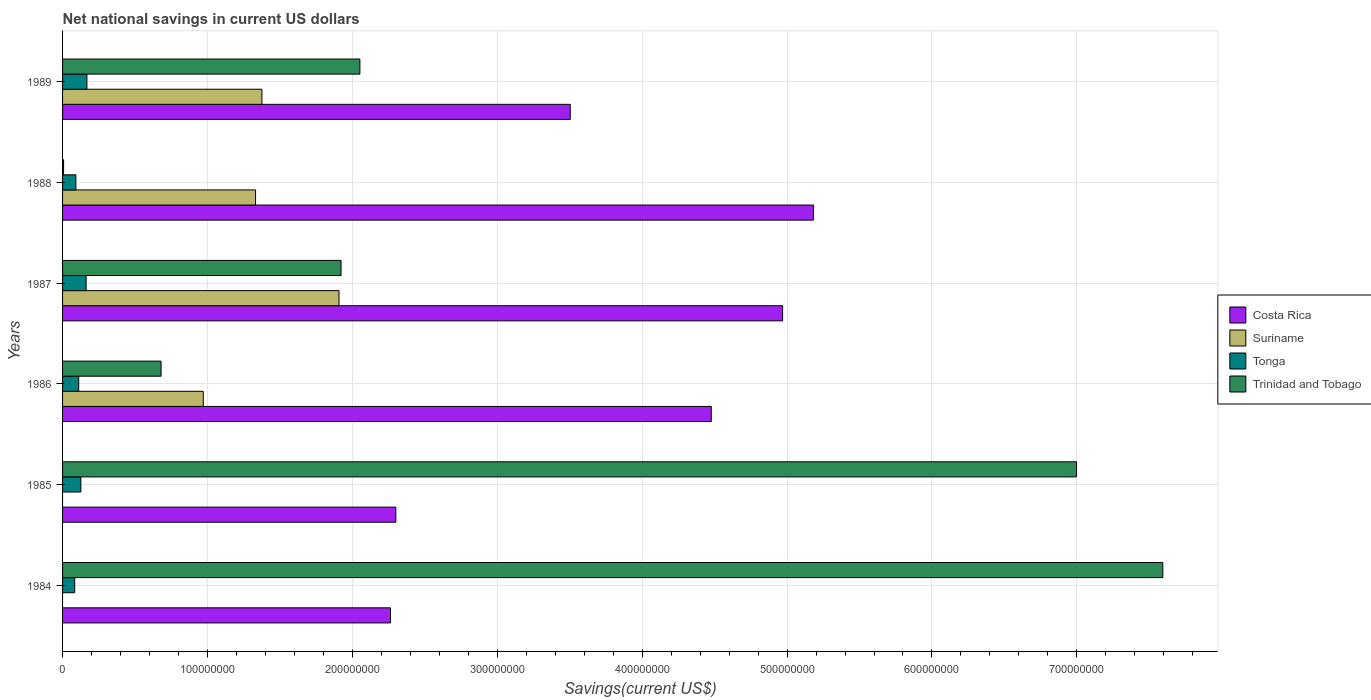How many different coloured bars are there?
Provide a succinct answer. 4. How many bars are there on the 6th tick from the bottom?
Offer a very short reply. 4. In how many cases, is the number of bars for a given year not equal to the number of legend labels?
Provide a succinct answer. 2. What is the net national savings in Tonga in 1986?
Provide a short and direct response. 1.11e+07. Across all years, what is the maximum net national savings in Trinidad and Tobago?
Your answer should be compact. 7.59e+08. Across all years, what is the minimum net national savings in Costa Rica?
Provide a short and direct response. 2.26e+08. In which year was the net national savings in Costa Rica maximum?
Make the answer very short. 1988. What is the total net national savings in Tonga in the graph?
Your answer should be compact. 7.44e+07. What is the difference between the net national savings in Trinidad and Tobago in 1986 and that in 1987?
Provide a short and direct response. -1.24e+08. What is the difference between the net national savings in Tonga in 1988 and the net national savings in Trinidad and Tobago in 1984?
Your response must be concise. -7.50e+08. What is the average net national savings in Suriname per year?
Keep it short and to the point. 9.31e+07. In the year 1988, what is the difference between the net national savings in Suriname and net national savings in Tonga?
Give a very brief answer. 1.24e+08. In how many years, is the net national savings in Suriname greater than 420000000 US$?
Offer a very short reply. 0. What is the ratio of the net national savings in Tonga in 1984 to that in 1989?
Your answer should be compact. 0.5. Is the net national savings in Costa Rica in 1984 less than that in 1986?
Offer a terse response. Yes. Is the difference between the net national savings in Suriname in 1988 and 1989 greater than the difference between the net national savings in Tonga in 1988 and 1989?
Provide a short and direct response. Yes. What is the difference between the highest and the second highest net national savings in Costa Rica?
Your answer should be compact. 2.13e+07. What is the difference between the highest and the lowest net national savings in Suriname?
Give a very brief answer. 1.91e+08. In how many years, is the net national savings in Tonga greater than the average net national savings in Tonga taken over all years?
Ensure brevity in your answer.  3. Is it the case that in every year, the sum of the net national savings in Trinidad and Tobago and net national savings in Tonga is greater than the sum of net national savings in Suriname and net national savings in Costa Rica?
Give a very brief answer. No. How many bars are there?
Give a very brief answer. 22. Are all the bars in the graph horizontal?
Give a very brief answer. Yes. How many years are there in the graph?
Your answer should be very brief. 6. What is the difference between two consecutive major ticks on the X-axis?
Make the answer very short. 1.00e+08. Does the graph contain any zero values?
Give a very brief answer. Yes. Does the graph contain grids?
Offer a very short reply. Yes. Where does the legend appear in the graph?
Provide a short and direct response. Center right. How many legend labels are there?
Ensure brevity in your answer.  4. How are the legend labels stacked?
Offer a very short reply. Vertical. What is the title of the graph?
Offer a very short reply. Net national savings in current US dollars. What is the label or title of the X-axis?
Offer a terse response. Savings(current US$). What is the label or title of the Y-axis?
Give a very brief answer. Years. What is the Savings(current US$) of Costa Rica in 1984?
Offer a very short reply. 2.26e+08. What is the Savings(current US$) in Suriname in 1984?
Provide a succinct answer. 0. What is the Savings(current US$) in Tonga in 1984?
Offer a terse response. 8.39e+06. What is the Savings(current US$) in Trinidad and Tobago in 1984?
Your answer should be very brief. 7.59e+08. What is the Savings(current US$) of Costa Rica in 1985?
Ensure brevity in your answer.  2.30e+08. What is the Savings(current US$) in Suriname in 1985?
Provide a succinct answer. 0. What is the Savings(current US$) in Tonga in 1985?
Keep it short and to the point. 1.26e+07. What is the Savings(current US$) in Trinidad and Tobago in 1985?
Make the answer very short. 7.00e+08. What is the Savings(current US$) in Costa Rica in 1986?
Make the answer very short. 4.48e+08. What is the Savings(current US$) of Suriname in 1986?
Your answer should be compact. 9.71e+07. What is the Savings(current US$) in Tonga in 1986?
Offer a terse response. 1.11e+07. What is the Savings(current US$) of Trinidad and Tobago in 1986?
Ensure brevity in your answer.  6.80e+07. What is the Savings(current US$) in Costa Rica in 1987?
Your answer should be very brief. 4.97e+08. What is the Savings(current US$) in Suriname in 1987?
Ensure brevity in your answer.  1.91e+08. What is the Savings(current US$) in Tonga in 1987?
Offer a terse response. 1.63e+07. What is the Savings(current US$) of Trinidad and Tobago in 1987?
Your answer should be compact. 1.92e+08. What is the Savings(current US$) of Costa Rica in 1988?
Offer a terse response. 5.18e+08. What is the Savings(current US$) of Suriname in 1988?
Your answer should be very brief. 1.33e+08. What is the Savings(current US$) of Tonga in 1988?
Provide a short and direct response. 9.19e+06. What is the Savings(current US$) in Trinidad and Tobago in 1988?
Keep it short and to the point. 7.15e+05. What is the Savings(current US$) in Costa Rica in 1989?
Provide a short and direct response. 3.50e+08. What is the Savings(current US$) in Suriname in 1989?
Ensure brevity in your answer.  1.38e+08. What is the Savings(current US$) of Tonga in 1989?
Offer a very short reply. 1.68e+07. What is the Savings(current US$) of Trinidad and Tobago in 1989?
Provide a short and direct response. 2.05e+08. Across all years, what is the maximum Savings(current US$) of Costa Rica?
Provide a succinct answer. 5.18e+08. Across all years, what is the maximum Savings(current US$) in Suriname?
Offer a terse response. 1.91e+08. Across all years, what is the maximum Savings(current US$) of Tonga?
Offer a terse response. 1.68e+07. Across all years, what is the maximum Savings(current US$) in Trinidad and Tobago?
Ensure brevity in your answer.  7.59e+08. Across all years, what is the minimum Savings(current US$) in Costa Rica?
Offer a very short reply. 2.26e+08. Across all years, what is the minimum Savings(current US$) in Suriname?
Offer a very short reply. 0. Across all years, what is the minimum Savings(current US$) in Tonga?
Make the answer very short. 8.39e+06. Across all years, what is the minimum Savings(current US$) of Trinidad and Tobago?
Provide a succinct answer. 7.15e+05. What is the total Savings(current US$) of Costa Rica in the graph?
Make the answer very short. 2.27e+09. What is the total Savings(current US$) in Suriname in the graph?
Your answer should be compact. 5.59e+08. What is the total Savings(current US$) in Tonga in the graph?
Ensure brevity in your answer.  7.44e+07. What is the total Savings(current US$) of Trinidad and Tobago in the graph?
Keep it short and to the point. 1.93e+09. What is the difference between the Savings(current US$) of Costa Rica in 1984 and that in 1985?
Make the answer very short. -3.69e+06. What is the difference between the Savings(current US$) in Tonga in 1984 and that in 1985?
Provide a short and direct response. -4.25e+06. What is the difference between the Savings(current US$) of Trinidad and Tobago in 1984 and that in 1985?
Your answer should be very brief. 5.95e+07. What is the difference between the Savings(current US$) in Costa Rica in 1984 and that in 1986?
Offer a very short reply. -2.21e+08. What is the difference between the Savings(current US$) of Tonga in 1984 and that in 1986?
Provide a succinct answer. -2.76e+06. What is the difference between the Savings(current US$) of Trinidad and Tobago in 1984 and that in 1986?
Offer a very short reply. 6.91e+08. What is the difference between the Savings(current US$) of Costa Rica in 1984 and that in 1987?
Offer a terse response. -2.71e+08. What is the difference between the Savings(current US$) of Tonga in 1984 and that in 1987?
Offer a terse response. -7.86e+06. What is the difference between the Savings(current US$) of Trinidad and Tobago in 1984 and that in 1987?
Ensure brevity in your answer.  5.67e+08. What is the difference between the Savings(current US$) in Costa Rica in 1984 and that in 1988?
Offer a very short reply. -2.92e+08. What is the difference between the Savings(current US$) in Tonga in 1984 and that in 1988?
Keep it short and to the point. -8.01e+05. What is the difference between the Savings(current US$) of Trinidad and Tobago in 1984 and that in 1988?
Ensure brevity in your answer.  7.59e+08. What is the difference between the Savings(current US$) in Costa Rica in 1984 and that in 1989?
Your response must be concise. -1.24e+08. What is the difference between the Savings(current US$) of Tonga in 1984 and that in 1989?
Give a very brief answer. -8.43e+06. What is the difference between the Savings(current US$) in Trinidad and Tobago in 1984 and that in 1989?
Your answer should be compact. 5.54e+08. What is the difference between the Savings(current US$) in Costa Rica in 1985 and that in 1986?
Offer a very short reply. -2.18e+08. What is the difference between the Savings(current US$) of Tonga in 1985 and that in 1986?
Your answer should be very brief. 1.49e+06. What is the difference between the Savings(current US$) in Trinidad and Tobago in 1985 and that in 1986?
Offer a terse response. 6.32e+08. What is the difference between the Savings(current US$) of Costa Rica in 1985 and that in 1987?
Make the answer very short. -2.67e+08. What is the difference between the Savings(current US$) of Tonga in 1985 and that in 1987?
Offer a terse response. -3.61e+06. What is the difference between the Savings(current US$) of Trinidad and Tobago in 1985 and that in 1987?
Make the answer very short. 5.08e+08. What is the difference between the Savings(current US$) in Costa Rica in 1985 and that in 1988?
Ensure brevity in your answer.  -2.88e+08. What is the difference between the Savings(current US$) in Tonga in 1985 and that in 1988?
Ensure brevity in your answer.  3.45e+06. What is the difference between the Savings(current US$) in Trinidad and Tobago in 1985 and that in 1988?
Your response must be concise. 6.99e+08. What is the difference between the Savings(current US$) of Costa Rica in 1985 and that in 1989?
Provide a succinct answer. -1.20e+08. What is the difference between the Savings(current US$) in Tonga in 1985 and that in 1989?
Provide a short and direct response. -4.18e+06. What is the difference between the Savings(current US$) in Trinidad and Tobago in 1985 and that in 1989?
Ensure brevity in your answer.  4.95e+08. What is the difference between the Savings(current US$) of Costa Rica in 1986 and that in 1987?
Offer a very short reply. -4.92e+07. What is the difference between the Savings(current US$) of Suriname in 1986 and that in 1987?
Provide a short and direct response. -9.37e+07. What is the difference between the Savings(current US$) of Tonga in 1986 and that in 1987?
Keep it short and to the point. -5.11e+06. What is the difference between the Savings(current US$) of Trinidad and Tobago in 1986 and that in 1987?
Your response must be concise. -1.24e+08. What is the difference between the Savings(current US$) of Costa Rica in 1986 and that in 1988?
Offer a very short reply. -7.05e+07. What is the difference between the Savings(current US$) in Suriname in 1986 and that in 1988?
Ensure brevity in your answer.  -3.61e+07. What is the difference between the Savings(current US$) in Tonga in 1986 and that in 1988?
Offer a very short reply. 1.96e+06. What is the difference between the Savings(current US$) in Trinidad and Tobago in 1986 and that in 1988?
Offer a very short reply. 6.73e+07. What is the difference between the Savings(current US$) in Costa Rica in 1986 and that in 1989?
Provide a succinct answer. 9.73e+07. What is the difference between the Savings(current US$) of Suriname in 1986 and that in 1989?
Provide a short and direct response. -4.05e+07. What is the difference between the Savings(current US$) of Tonga in 1986 and that in 1989?
Provide a short and direct response. -5.67e+06. What is the difference between the Savings(current US$) in Trinidad and Tobago in 1986 and that in 1989?
Provide a succinct answer. -1.37e+08. What is the difference between the Savings(current US$) of Costa Rica in 1987 and that in 1988?
Give a very brief answer. -2.13e+07. What is the difference between the Savings(current US$) of Suriname in 1987 and that in 1988?
Give a very brief answer. 5.76e+07. What is the difference between the Savings(current US$) in Tonga in 1987 and that in 1988?
Provide a short and direct response. 7.06e+06. What is the difference between the Savings(current US$) in Trinidad and Tobago in 1987 and that in 1988?
Provide a short and direct response. 1.91e+08. What is the difference between the Savings(current US$) in Costa Rica in 1987 and that in 1989?
Provide a short and direct response. 1.47e+08. What is the difference between the Savings(current US$) in Suriname in 1987 and that in 1989?
Provide a succinct answer. 5.32e+07. What is the difference between the Savings(current US$) of Tonga in 1987 and that in 1989?
Offer a very short reply. -5.68e+05. What is the difference between the Savings(current US$) of Trinidad and Tobago in 1987 and that in 1989?
Offer a very short reply. -1.30e+07. What is the difference between the Savings(current US$) in Costa Rica in 1988 and that in 1989?
Provide a short and direct response. 1.68e+08. What is the difference between the Savings(current US$) of Suriname in 1988 and that in 1989?
Make the answer very short. -4.38e+06. What is the difference between the Savings(current US$) of Tonga in 1988 and that in 1989?
Ensure brevity in your answer.  -7.63e+06. What is the difference between the Savings(current US$) of Trinidad and Tobago in 1988 and that in 1989?
Offer a very short reply. -2.04e+08. What is the difference between the Savings(current US$) of Costa Rica in 1984 and the Savings(current US$) of Tonga in 1985?
Provide a short and direct response. 2.14e+08. What is the difference between the Savings(current US$) of Costa Rica in 1984 and the Savings(current US$) of Trinidad and Tobago in 1985?
Your response must be concise. -4.73e+08. What is the difference between the Savings(current US$) of Tonga in 1984 and the Savings(current US$) of Trinidad and Tobago in 1985?
Keep it short and to the point. -6.91e+08. What is the difference between the Savings(current US$) of Costa Rica in 1984 and the Savings(current US$) of Suriname in 1986?
Provide a short and direct response. 1.29e+08. What is the difference between the Savings(current US$) in Costa Rica in 1984 and the Savings(current US$) in Tonga in 1986?
Your response must be concise. 2.15e+08. What is the difference between the Savings(current US$) of Costa Rica in 1984 and the Savings(current US$) of Trinidad and Tobago in 1986?
Your answer should be compact. 1.58e+08. What is the difference between the Savings(current US$) of Tonga in 1984 and the Savings(current US$) of Trinidad and Tobago in 1986?
Your answer should be compact. -5.96e+07. What is the difference between the Savings(current US$) of Costa Rica in 1984 and the Savings(current US$) of Suriname in 1987?
Your answer should be very brief. 3.55e+07. What is the difference between the Savings(current US$) in Costa Rica in 1984 and the Savings(current US$) in Tonga in 1987?
Your response must be concise. 2.10e+08. What is the difference between the Savings(current US$) in Costa Rica in 1984 and the Savings(current US$) in Trinidad and Tobago in 1987?
Offer a very short reply. 3.41e+07. What is the difference between the Savings(current US$) of Tonga in 1984 and the Savings(current US$) of Trinidad and Tobago in 1987?
Your answer should be very brief. -1.84e+08. What is the difference between the Savings(current US$) of Costa Rica in 1984 and the Savings(current US$) of Suriname in 1988?
Offer a very short reply. 9.31e+07. What is the difference between the Savings(current US$) in Costa Rica in 1984 and the Savings(current US$) in Tonga in 1988?
Keep it short and to the point. 2.17e+08. What is the difference between the Savings(current US$) in Costa Rica in 1984 and the Savings(current US$) in Trinidad and Tobago in 1988?
Provide a short and direct response. 2.26e+08. What is the difference between the Savings(current US$) of Tonga in 1984 and the Savings(current US$) of Trinidad and Tobago in 1988?
Keep it short and to the point. 7.67e+06. What is the difference between the Savings(current US$) of Costa Rica in 1984 and the Savings(current US$) of Suriname in 1989?
Offer a very short reply. 8.87e+07. What is the difference between the Savings(current US$) of Costa Rica in 1984 and the Savings(current US$) of Tonga in 1989?
Make the answer very short. 2.09e+08. What is the difference between the Savings(current US$) in Costa Rica in 1984 and the Savings(current US$) in Trinidad and Tobago in 1989?
Provide a short and direct response. 2.11e+07. What is the difference between the Savings(current US$) of Tonga in 1984 and the Savings(current US$) of Trinidad and Tobago in 1989?
Ensure brevity in your answer.  -1.97e+08. What is the difference between the Savings(current US$) of Costa Rica in 1985 and the Savings(current US$) of Suriname in 1986?
Your answer should be very brief. 1.33e+08. What is the difference between the Savings(current US$) of Costa Rica in 1985 and the Savings(current US$) of Tonga in 1986?
Your response must be concise. 2.19e+08. What is the difference between the Savings(current US$) in Costa Rica in 1985 and the Savings(current US$) in Trinidad and Tobago in 1986?
Your answer should be compact. 1.62e+08. What is the difference between the Savings(current US$) in Tonga in 1985 and the Savings(current US$) in Trinidad and Tobago in 1986?
Give a very brief answer. -5.53e+07. What is the difference between the Savings(current US$) in Costa Rica in 1985 and the Savings(current US$) in Suriname in 1987?
Your answer should be very brief. 3.92e+07. What is the difference between the Savings(current US$) of Costa Rica in 1985 and the Savings(current US$) of Tonga in 1987?
Your answer should be very brief. 2.14e+08. What is the difference between the Savings(current US$) in Costa Rica in 1985 and the Savings(current US$) in Trinidad and Tobago in 1987?
Your answer should be compact. 3.78e+07. What is the difference between the Savings(current US$) in Tonga in 1985 and the Savings(current US$) in Trinidad and Tobago in 1987?
Keep it short and to the point. -1.80e+08. What is the difference between the Savings(current US$) in Costa Rica in 1985 and the Savings(current US$) in Suriname in 1988?
Your answer should be very brief. 9.68e+07. What is the difference between the Savings(current US$) in Costa Rica in 1985 and the Savings(current US$) in Tonga in 1988?
Keep it short and to the point. 2.21e+08. What is the difference between the Savings(current US$) of Costa Rica in 1985 and the Savings(current US$) of Trinidad and Tobago in 1988?
Your response must be concise. 2.29e+08. What is the difference between the Savings(current US$) in Tonga in 1985 and the Savings(current US$) in Trinidad and Tobago in 1988?
Your answer should be compact. 1.19e+07. What is the difference between the Savings(current US$) of Costa Rica in 1985 and the Savings(current US$) of Suriname in 1989?
Your response must be concise. 9.24e+07. What is the difference between the Savings(current US$) in Costa Rica in 1985 and the Savings(current US$) in Tonga in 1989?
Give a very brief answer. 2.13e+08. What is the difference between the Savings(current US$) in Costa Rica in 1985 and the Savings(current US$) in Trinidad and Tobago in 1989?
Your answer should be very brief. 2.48e+07. What is the difference between the Savings(current US$) of Tonga in 1985 and the Savings(current US$) of Trinidad and Tobago in 1989?
Keep it short and to the point. -1.93e+08. What is the difference between the Savings(current US$) in Costa Rica in 1986 and the Savings(current US$) in Suriname in 1987?
Your answer should be very brief. 2.57e+08. What is the difference between the Savings(current US$) of Costa Rica in 1986 and the Savings(current US$) of Tonga in 1987?
Provide a succinct answer. 4.31e+08. What is the difference between the Savings(current US$) of Costa Rica in 1986 and the Savings(current US$) of Trinidad and Tobago in 1987?
Offer a terse response. 2.56e+08. What is the difference between the Savings(current US$) of Suriname in 1986 and the Savings(current US$) of Tonga in 1987?
Provide a succinct answer. 8.09e+07. What is the difference between the Savings(current US$) of Suriname in 1986 and the Savings(current US$) of Trinidad and Tobago in 1987?
Keep it short and to the point. -9.51e+07. What is the difference between the Savings(current US$) of Tonga in 1986 and the Savings(current US$) of Trinidad and Tobago in 1987?
Ensure brevity in your answer.  -1.81e+08. What is the difference between the Savings(current US$) in Costa Rica in 1986 and the Savings(current US$) in Suriname in 1988?
Keep it short and to the point. 3.15e+08. What is the difference between the Savings(current US$) of Costa Rica in 1986 and the Savings(current US$) of Tonga in 1988?
Ensure brevity in your answer.  4.39e+08. What is the difference between the Savings(current US$) of Costa Rica in 1986 and the Savings(current US$) of Trinidad and Tobago in 1988?
Your response must be concise. 4.47e+08. What is the difference between the Savings(current US$) in Suriname in 1986 and the Savings(current US$) in Tonga in 1988?
Your answer should be compact. 8.79e+07. What is the difference between the Savings(current US$) of Suriname in 1986 and the Savings(current US$) of Trinidad and Tobago in 1988?
Offer a terse response. 9.64e+07. What is the difference between the Savings(current US$) in Tonga in 1986 and the Savings(current US$) in Trinidad and Tobago in 1988?
Offer a very short reply. 1.04e+07. What is the difference between the Savings(current US$) of Costa Rica in 1986 and the Savings(current US$) of Suriname in 1989?
Your response must be concise. 3.10e+08. What is the difference between the Savings(current US$) in Costa Rica in 1986 and the Savings(current US$) in Tonga in 1989?
Your answer should be very brief. 4.31e+08. What is the difference between the Savings(current US$) in Costa Rica in 1986 and the Savings(current US$) in Trinidad and Tobago in 1989?
Provide a short and direct response. 2.43e+08. What is the difference between the Savings(current US$) of Suriname in 1986 and the Savings(current US$) of Tonga in 1989?
Offer a very short reply. 8.03e+07. What is the difference between the Savings(current US$) of Suriname in 1986 and the Savings(current US$) of Trinidad and Tobago in 1989?
Your response must be concise. -1.08e+08. What is the difference between the Savings(current US$) in Tonga in 1986 and the Savings(current US$) in Trinidad and Tobago in 1989?
Offer a terse response. -1.94e+08. What is the difference between the Savings(current US$) of Costa Rica in 1987 and the Savings(current US$) of Suriname in 1988?
Offer a terse response. 3.64e+08. What is the difference between the Savings(current US$) in Costa Rica in 1987 and the Savings(current US$) in Tonga in 1988?
Offer a very short reply. 4.88e+08. What is the difference between the Savings(current US$) of Costa Rica in 1987 and the Savings(current US$) of Trinidad and Tobago in 1988?
Your answer should be compact. 4.96e+08. What is the difference between the Savings(current US$) in Suriname in 1987 and the Savings(current US$) in Tonga in 1988?
Keep it short and to the point. 1.82e+08. What is the difference between the Savings(current US$) in Suriname in 1987 and the Savings(current US$) in Trinidad and Tobago in 1988?
Make the answer very short. 1.90e+08. What is the difference between the Savings(current US$) of Tonga in 1987 and the Savings(current US$) of Trinidad and Tobago in 1988?
Give a very brief answer. 1.55e+07. What is the difference between the Savings(current US$) in Costa Rica in 1987 and the Savings(current US$) in Suriname in 1989?
Your answer should be compact. 3.59e+08. What is the difference between the Savings(current US$) of Costa Rica in 1987 and the Savings(current US$) of Tonga in 1989?
Make the answer very short. 4.80e+08. What is the difference between the Savings(current US$) of Costa Rica in 1987 and the Savings(current US$) of Trinidad and Tobago in 1989?
Provide a short and direct response. 2.92e+08. What is the difference between the Savings(current US$) in Suriname in 1987 and the Savings(current US$) in Tonga in 1989?
Provide a succinct answer. 1.74e+08. What is the difference between the Savings(current US$) of Suriname in 1987 and the Savings(current US$) of Trinidad and Tobago in 1989?
Ensure brevity in your answer.  -1.44e+07. What is the difference between the Savings(current US$) in Tonga in 1987 and the Savings(current US$) in Trinidad and Tobago in 1989?
Ensure brevity in your answer.  -1.89e+08. What is the difference between the Savings(current US$) in Costa Rica in 1988 and the Savings(current US$) in Suriname in 1989?
Provide a short and direct response. 3.81e+08. What is the difference between the Savings(current US$) in Costa Rica in 1988 and the Savings(current US$) in Tonga in 1989?
Give a very brief answer. 5.01e+08. What is the difference between the Savings(current US$) in Costa Rica in 1988 and the Savings(current US$) in Trinidad and Tobago in 1989?
Your response must be concise. 3.13e+08. What is the difference between the Savings(current US$) in Suriname in 1988 and the Savings(current US$) in Tonga in 1989?
Ensure brevity in your answer.  1.16e+08. What is the difference between the Savings(current US$) in Suriname in 1988 and the Savings(current US$) in Trinidad and Tobago in 1989?
Provide a succinct answer. -7.20e+07. What is the difference between the Savings(current US$) in Tonga in 1988 and the Savings(current US$) in Trinidad and Tobago in 1989?
Give a very brief answer. -1.96e+08. What is the average Savings(current US$) of Costa Rica per year?
Your response must be concise. 3.78e+08. What is the average Savings(current US$) of Suriname per year?
Offer a very short reply. 9.31e+07. What is the average Savings(current US$) of Tonga per year?
Make the answer very short. 1.24e+07. What is the average Savings(current US$) of Trinidad and Tobago per year?
Ensure brevity in your answer.  3.21e+08. In the year 1984, what is the difference between the Savings(current US$) in Costa Rica and Savings(current US$) in Tonga?
Your answer should be compact. 2.18e+08. In the year 1984, what is the difference between the Savings(current US$) of Costa Rica and Savings(current US$) of Trinidad and Tobago?
Your response must be concise. -5.33e+08. In the year 1984, what is the difference between the Savings(current US$) of Tonga and Savings(current US$) of Trinidad and Tobago?
Provide a succinct answer. -7.51e+08. In the year 1985, what is the difference between the Savings(current US$) in Costa Rica and Savings(current US$) in Tonga?
Ensure brevity in your answer.  2.17e+08. In the year 1985, what is the difference between the Savings(current US$) of Costa Rica and Savings(current US$) of Trinidad and Tobago?
Ensure brevity in your answer.  -4.70e+08. In the year 1985, what is the difference between the Savings(current US$) in Tonga and Savings(current US$) in Trinidad and Tobago?
Your answer should be compact. -6.87e+08. In the year 1986, what is the difference between the Savings(current US$) in Costa Rica and Savings(current US$) in Suriname?
Ensure brevity in your answer.  3.51e+08. In the year 1986, what is the difference between the Savings(current US$) of Costa Rica and Savings(current US$) of Tonga?
Your answer should be very brief. 4.37e+08. In the year 1986, what is the difference between the Savings(current US$) of Costa Rica and Savings(current US$) of Trinidad and Tobago?
Give a very brief answer. 3.80e+08. In the year 1986, what is the difference between the Savings(current US$) of Suriname and Savings(current US$) of Tonga?
Offer a very short reply. 8.60e+07. In the year 1986, what is the difference between the Savings(current US$) in Suriname and Savings(current US$) in Trinidad and Tobago?
Give a very brief answer. 2.91e+07. In the year 1986, what is the difference between the Savings(current US$) of Tonga and Savings(current US$) of Trinidad and Tobago?
Keep it short and to the point. -5.68e+07. In the year 1987, what is the difference between the Savings(current US$) of Costa Rica and Savings(current US$) of Suriname?
Your response must be concise. 3.06e+08. In the year 1987, what is the difference between the Savings(current US$) of Costa Rica and Savings(current US$) of Tonga?
Offer a terse response. 4.81e+08. In the year 1987, what is the difference between the Savings(current US$) in Costa Rica and Savings(current US$) in Trinidad and Tobago?
Give a very brief answer. 3.05e+08. In the year 1987, what is the difference between the Savings(current US$) in Suriname and Savings(current US$) in Tonga?
Your response must be concise. 1.75e+08. In the year 1987, what is the difference between the Savings(current US$) in Suriname and Savings(current US$) in Trinidad and Tobago?
Provide a succinct answer. -1.40e+06. In the year 1987, what is the difference between the Savings(current US$) of Tonga and Savings(current US$) of Trinidad and Tobago?
Keep it short and to the point. -1.76e+08. In the year 1988, what is the difference between the Savings(current US$) in Costa Rica and Savings(current US$) in Suriname?
Your answer should be compact. 3.85e+08. In the year 1988, what is the difference between the Savings(current US$) of Costa Rica and Savings(current US$) of Tonga?
Make the answer very short. 5.09e+08. In the year 1988, what is the difference between the Savings(current US$) in Costa Rica and Savings(current US$) in Trinidad and Tobago?
Make the answer very short. 5.17e+08. In the year 1988, what is the difference between the Savings(current US$) of Suriname and Savings(current US$) of Tonga?
Ensure brevity in your answer.  1.24e+08. In the year 1988, what is the difference between the Savings(current US$) of Suriname and Savings(current US$) of Trinidad and Tobago?
Provide a succinct answer. 1.32e+08. In the year 1988, what is the difference between the Savings(current US$) of Tonga and Savings(current US$) of Trinidad and Tobago?
Your answer should be very brief. 8.47e+06. In the year 1989, what is the difference between the Savings(current US$) of Costa Rica and Savings(current US$) of Suriname?
Make the answer very short. 2.13e+08. In the year 1989, what is the difference between the Savings(current US$) of Costa Rica and Savings(current US$) of Tonga?
Provide a succinct answer. 3.34e+08. In the year 1989, what is the difference between the Savings(current US$) in Costa Rica and Savings(current US$) in Trinidad and Tobago?
Give a very brief answer. 1.45e+08. In the year 1989, what is the difference between the Savings(current US$) of Suriname and Savings(current US$) of Tonga?
Offer a very short reply. 1.21e+08. In the year 1989, what is the difference between the Savings(current US$) of Suriname and Savings(current US$) of Trinidad and Tobago?
Keep it short and to the point. -6.76e+07. In the year 1989, what is the difference between the Savings(current US$) of Tonga and Savings(current US$) of Trinidad and Tobago?
Ensure brevity in your answer.  -1.88e+08. What is the ratio of the Savings(current US$) in Costa Rica in 1984 to that in 1985?
Provide a succinct answer. 0.98. What is the ratio of the Savings(current US$) of Tonga in 1984 to that in 1985?
Your response must be concise. 0.66. What is the ratio of the Savings(current US$) in Trinidad and Tobago in 1984 to that in 1985?
Keep it short and to the point. 1.09. What is the ratio of the Savings(current US$) of Costa Rica in 1984 to that in 1986?
Make the answer very short. 0.51. What is the ratio of the Savings(current US$) in Tonga in 1984 to that in 1986?
Make the answer very short. 0.75. What is the ratio of the Savings(current US$) of Trinidad and Tobago in 1984 to that in 1986?
Offer a very short reply. 11.17. What is the ratio of the Savings(current US$) of Costa Rica in 1984 to that in 1987?
Ensure brevity in your answer.  0.46. What is the ratio of the Savings(current US$) in Tonga in 1984 to that in 1987?
Keep it short and to the point. 0.52. What is the ratio of the Savings(current US$) of Trinidad and Tobago in 1984 to that in 1987?
Ensure brevity in your answer.  3.95. What is the ratio of the Savings(current US$) in Costa Rica in 1984 to that in 1988?
Offer a very short reply. 0.44. What is the ratio of the Savings(current US$) in Tonga in 1984 to that in 1988?
Give a very brief answer. 0.91. What is the ratio of the Savings(current US$) of Trinidad and Tobago in 1984 to that in 1988?
Offer a terse response. 1062.61. What is the ratio of the Savings(current US$) in Costa Rica in 1984 to that in 1989?
Ensure brevity in your answer.  0.65. What is the ratio of the Savings(current US$) of Tonga in 1984 to that in 1989?
Keep it short and to the point. 0.5. What is the ratio of the Savings(current US$) of Trinidad and Tobago in 1984 to that in 1989?
Provide a succinct answer. 3.7. What is the ratio of the Savings(current US$) of Costa Rica in 1985 to that in 1986?
Make the answer very short. 0.51. What is the ratio of the Savings(current US$) of Tonga in 1985 to that in 1986?
Give a very brief answer. 1.13. What is the ratio of the Savings(current US$) of Trinidad and Tobago in 1985 to that in 1986?
Make the answer very short. 10.29. What is the ratio of the Savings(current US$) in Costa Rica in 1985 to that in 1987?
Keep it short and to the point. 0.46. What is the ratio of the Savings(current US$) of Tonga in 1985 to that in 1987?
Keep it short and to the point. 0.78. What is the ratio of the Savings(current US$) of Trinidad and Tobago in 1985 to that in 1987?
Ensure brevity in your answer.  3.64. What is the ratio of the Savings(current US$) of Costa Rica in 1985 to that in 1988?
Your answer should be very brief. 0.44. What is the ratio of the Savings(current US$) of Tonga in 1985 to that in 1988?
Provide a short and direct response. 1.38. What is the ratio of the Savings(current US$) of Trinidad and Tobago in 1985 to that in 1988?
Keep it short and to the point. 979.29. What is the ratio of the Savings(current US$) in Costa Rica in 1985 to that in 1989?
Offer a very short reply. 0.66. What is the ratio of the Savings(current US$) of Tonga in 1985 to that in 1989?
Give a very brief answer. 0.75. What is the ratio of the Savings(current US$) in Trinidad and Tobago in 1985 to that in 1989?
Keep it short and to the point. 3.41. What is the ratio of the Savings(current US$) of Costa Rica in 1986 to that in 1987?
Ensure brevity in your answer.  0.9. What is the ratio of the Savings(current US$) in Suriname in 1986 to that in 1987?
Keep it short and to the point. 0.51. What is the ratio of the Savings(current US$) in Tonga in 1986 to that in 1987?
Your answer should be very brief. 0.69. What is the ratio of the Savings(current US$) in Trinidad and Tobago in 1986 to that in 1987?
Your response must be concise. 0.35. What is the ratio of the Savings(current US$) of Costa Rica in 1986 to that in 1988?
Ensure brevity in your answer.  0.86. What is the ratio of the Savings(current US$) of Suriname in 1986 to that in 1988?
Provide a succinct answer. 0.73. What is the ratio of the Savings(current US$) of Tonga in 1986 to that in 1988?
Ensure brevity in your answer.  1.21. What is the ratio of the Savings(current US$) in Trinidad and Tobago in 1986 to that in 1988?
Provide a short and direct response. 95.13. What is the ratio of the Savings(current US$) in Costa Rica in 1986 to that in 1989?
Provide a short and direct response. 1.28. What is the ratio of the Savings(current US$) in Suriname in 1986 to that in 1989?
Your answer should be compact. 0.71. What is the ratio of the Savings(current US$) of Tonga in 1986 to that in 1989?
Provide a short and direct response. 0.66. What is the ratio of the Savings(current US$) of Trinidad and Tobago in 1986 to that in 1989?
Make the answer very short. 0.33. What is the ratio of the Savings(current US$) in Costa Rica in 1987 to that in 1988?
Provide a succinct answer. 0.96. What is the ratio of the Savings(current US$) in Suriname in 1987 to that in 1988?
Keep it short and to the point. 1.43. What is the ratio of the Savings(current US$) in Tonga in 1987 to that in 1988?
Keep it short and to the point. 1.77. What is the ratio of the Savings(current US$) of Trinidad and Tobago in 1987 to that in 1988?
Your answer should be compact. 268.94. What is the ratio of the Savings(current US$) of Costa Rica in 1987 to that in 1989?
Provide a succinct answer. 1.42. What is the ratio of the Savings(current US$) of Suriname in 1987 to that in 1989?
Make the answer very short. 1.39. What is the ratio of the Savings(current US$) of Tonga in 1987 to that in 1989?
Your answer should be compact. 0.97. What is the ratio of the Savings(current US$) in Trinidad and Tobago in 1987 to that in 1989?
Provide a short and direct response. 0.94. What is the ratio of the Savings(current US$) in Costa Rica in 1988 to that in 1989?
Give a very brief answer. 1.48. What is the ratio of the Savings(current US$) in Suriname in 1988 to that in 1989?
Keep it short and to the point. 0.97. What is the ratio of the Savings(current US$) of Tonga in 1988 to that in 1989?
Give a very brief answer. 0.55. What is the ratio of the Savings(current US$) in Trinidad and Tobago in 1988 to that in 1989?
Provide a short and direct response. 0. What is the difference between the highest and the second highest Savings(current US$) of Costa Rica?
Provide a succinct answer. 2.13e+07. What is the difference between the highest and the second highest Savings(current US$) in Suriname?
Offer a very short reply. 5.32e+07. What is the difference between the highest and the second highest Savings(current US$) in Tonga?
Give a very brief answer. 5.68e+05. What is the difference between the highest and the second highest Savings(current US$) in Trinidad and Tobago?
Provide a short and direct response. 5.95e+07. What is the difference between the highest and the lowest Savings(current US$) in Costa Rica?
Your response must be concise. 2.92e+08. What is the difference between the highest and the lowest Savings(current US$) of Suriname?
Your answer should be very brief. 1.91e+08. What is the difference between the highest and the lowest Savings(current US$) in Tonga?
Your response must be concise. 8.43e+06. What is the difference between the highest and the lowest Savings(current US$) of Trinidad and Tobago?
Keep it short and to the point. 7.59e+08. 